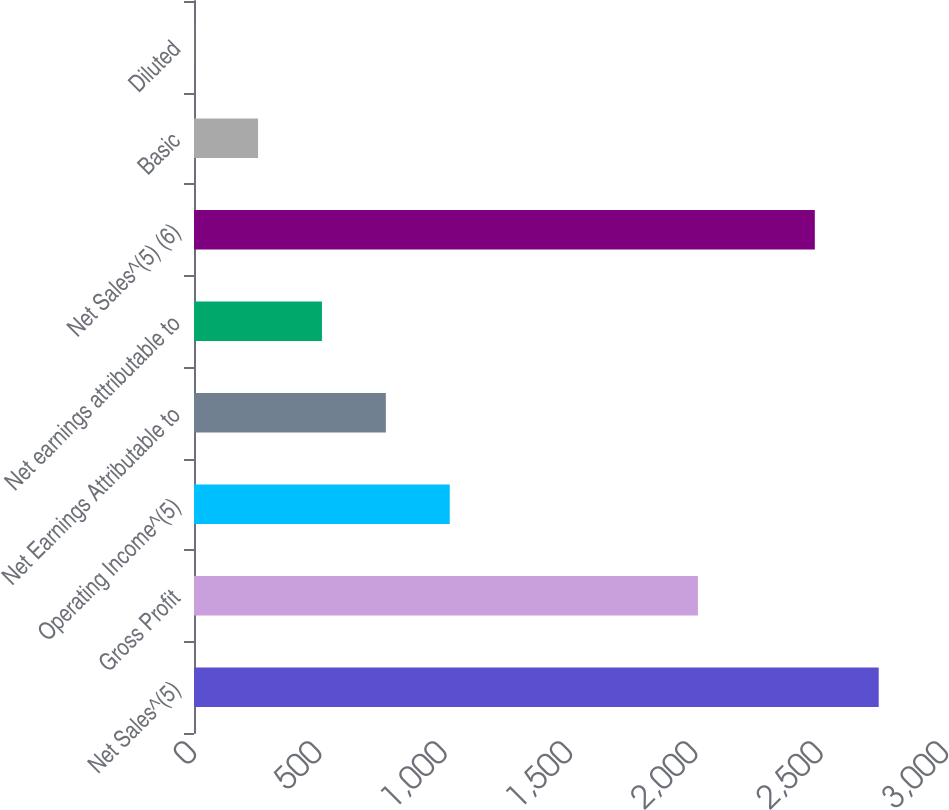Convert chart. <chart><loc_0><loc_0><loc_500><loc_500><bar_chart><fcel>Net Sales^(5)<fcel>Gross Profit<fcel>Operating Income^(5)<fcel>Net Earnings Attributable to<fcel>Net earnings attributable to<fcel>Net Sales^(5) (6)<fcel>Basic<fcel>Diluted<nl><fcel>2731.58<fcel>2010.3<fcel>1020.22<fcel>765.34<fcel>510.46<fcel>2476.7<fcel>255.58<fcel>0.7<nl></chart> 